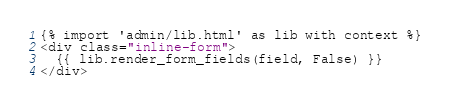Convert code to text. <code><loc_0><loc_0><loc_500><loc_500><_HTML_>{% import 'admin/lib.html' as lib with context %}
<div class="inline-form">
  {{ lib.render_form_fields(field, False) }}
</div>
</code> 